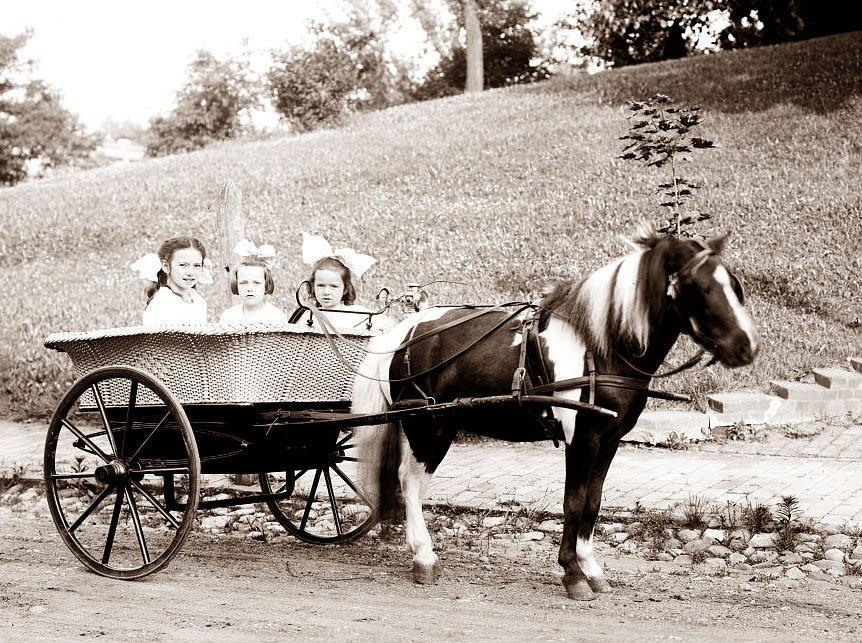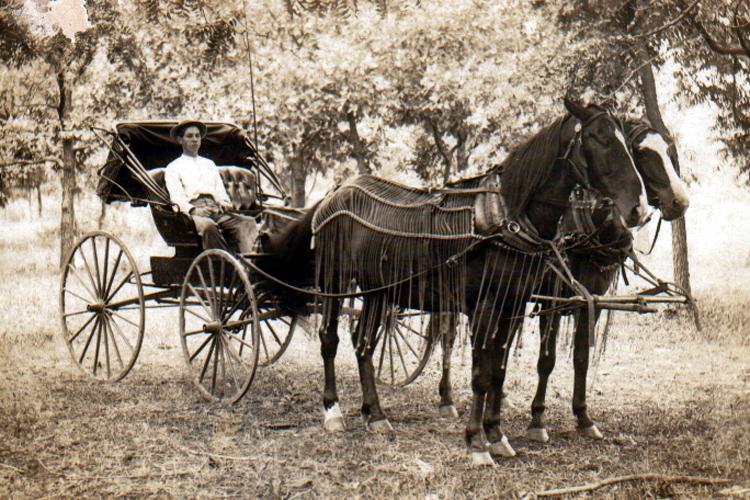The first image is the image on the left, the second image is the image on the right. Assess this claim about the two images: "In one of the images there is  a carriage with two horses hitched to it.". Correct or not? Answer yes or no. Yes. 